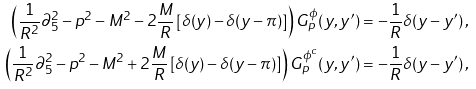<formula> <loc_0><loc_0><loc_500><loc_500>\left ( \frac { 1 } { R ^ { 2 } } \partial _ { 5 } ^ { 2 } - p ^ { 2 } - M ^ { 2 } - 2 \frac { M } { R } \left [ \delta ( y ) - \delta ( y - \pi ) \right ] \right ) G _ { p } ^ { \phi } ( y , y ^ { \prime } ) & = - \frac { 1 } { R } \delta ( y - y ^ { \prime } ) \, , \\ \left ( \frac { 1 } { R ^ { 2 } } \partial _ { 5 } ^ { 2 } - p ^ { 2 } - M ^ { 2 } + 2 \frac { M } { R } \left [ \delta ( y ) - \delta ( y - \pi ) \right ] \right ) G _ { p } ^ { \phi ^ { c } } ( y , y ^ { \prime } ) & = - \frac { 1 } { R } \delta ( y - y ^ { \prime } ) \, ,</formula> 